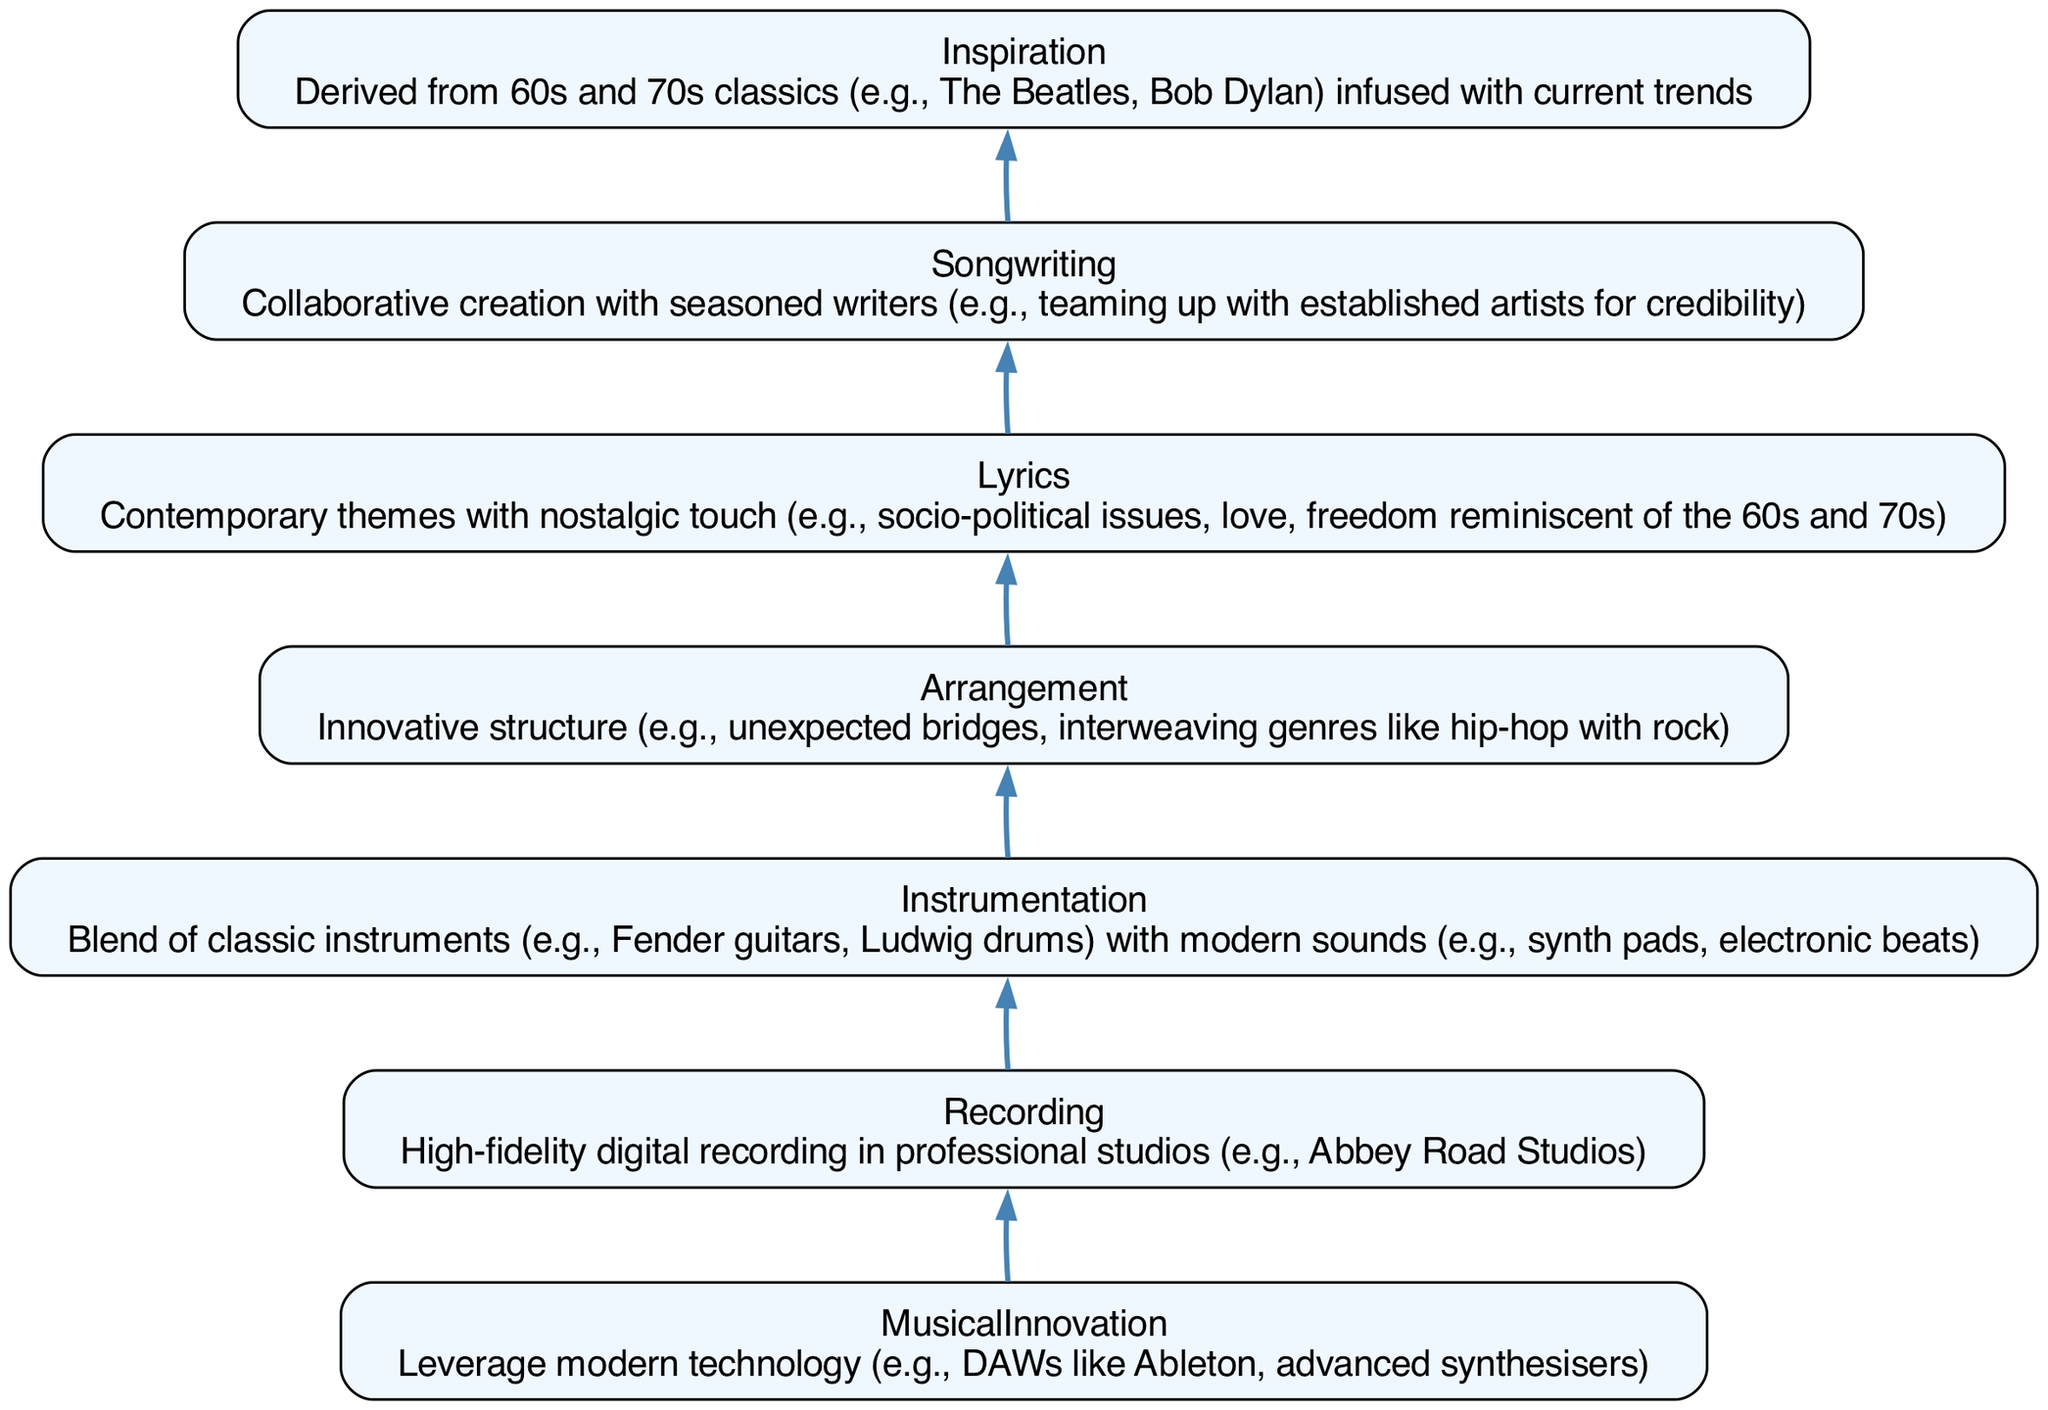What is the first stage in the flowchart? The first stage listed in the flowchart is "Inspiration," which is derived from 60s and 70s classics and current trends.
Answer: Inspiration How many stages are present in the diagram? The stages in the diagram are "Inspiration," "Songwriting," "Lyrics," "Arrangement," "Instrumentation," "Recording," and "Musical Innovation." This totals to seven distinct stages.
Answer: 7 What is the last stage highlighted in the flowchart? The last stage at the top of the flowchart is "Musical Innovation," which involves leveraging modern technology.
Answer: Musical Innovation Which two stages are connected by an edge that showcases an innovative songwriting process? The stages connected by this edge are "Inspiration" and "Songwriting," indicating that the song is inspired by classics and written collaboratively with established artists.
Answer: Inspiration and Songwriting What theme is emphasized in the "Lyrics" stage? The "Lyrics" stage emphasizes contemporary themes along with a nostalgic touch, referencing socio-political issues and love.
Answer: Contemporary themes with nostalgic touch What is a characteristic of the "Arrangement" stage? The "Arrangement" stage is characterized by an innovative structure, featuring unexpected bridges and interweaving genres like hip-hop with rock.
Answer: Innovative structure What is a key technology mentioned in the "Musical Innovation" stage? The "Musical Innovation" stage mentions the use of modern technology such as DAWs like Ableton as a key component.
Answer: DAWs like Ableton Why is collaboration emphasized in the "Songwriting" stage? Collaboration is emphasized in the "Songwriting" stage because it involves teaming up with seasoned writers to enhance credibility in the music industry.
Answer: Teaming up with established artists for credibility What type of instruments are combined in the "Instrumentation" stage? The "Instrumentation" stage features a blend of classic instruments like Fender guitars and Ludwig drums mixed with modern sounds such as sync pads and electronic beats.
Answer: Classic instruments and modern sounds 